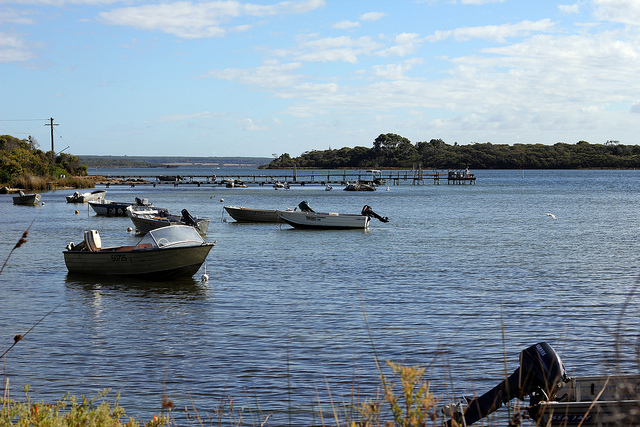How can one describe the tranquility of this scene? The tranquility of this scene can be characterized by the gentle presence of several boats floating serenely on a vast, still lake, framed by the soft blues of a cloudy sky. These boats, some nestling closer to a distant dock and others lingering farther out, contribute to a sense of calm and uninterrupted peace. The water’s smooth surface enhances the sense of stillness, while a solitary bird gliding gracefully through the scene adds a touch of natural harmony. The gentle rustling of nearby reeds complements the serene atmosphere, making it an ideal escape for anyone looking to unwind and find solace away from the noise and rush of everyday life. 